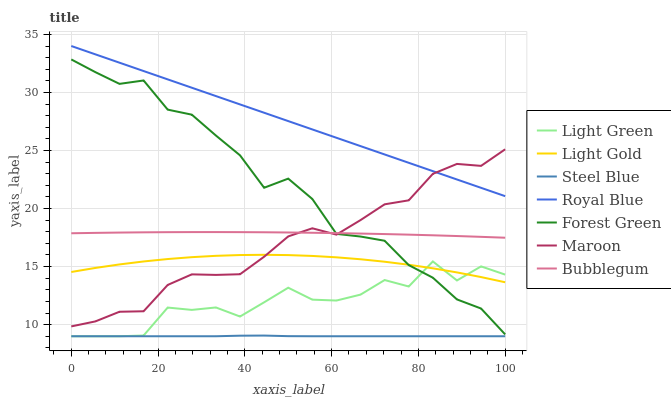Does Maroon have the minimum area under the curve?
Answer yes or no. No. Does Maroon have the maximum area under the curve?
Answer yes or no. No. Is Maroon the smoothest?
Answer yes or no. No. Is Maroon the roughest?
Answer yes or no. No. Does Maroon have the lowest value?
Answer yes or no. No. Does Maroon have the highest value?
Answer yes or no. No. Is Light Gold less than Royal Blue?
Answer yes or no. Yes. Is Royal Blue greater than Forest Green?
Answer yes or no. Yes. Does Light Gold intersect Royal Blue?
Answer yes or no. No. 